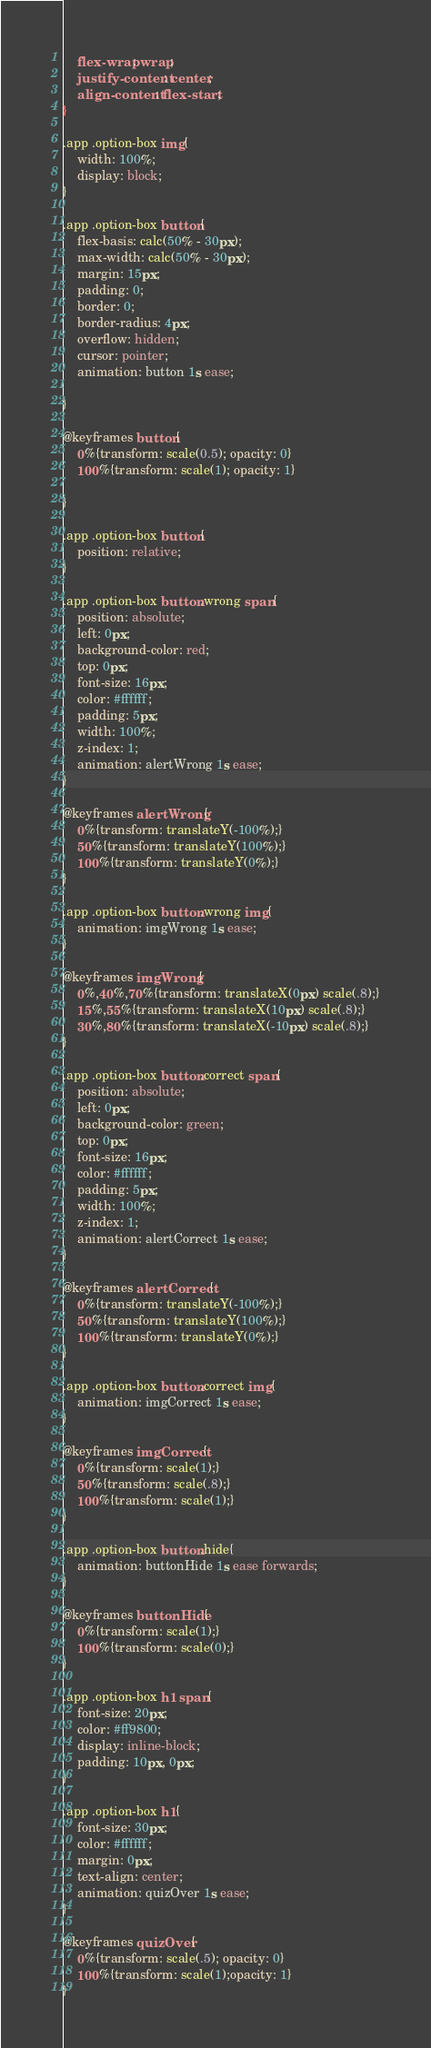Convert code to text. <code><loc_0><loc_0><loc_500><loc_500><_CSS_>	flex-wrap: wrap;
	justify-content: center;
	align-content: flex-start;
}

.app .option-box img{
	width: 100%;
	display: block;
}

.app .option-box button{
	flex-basis: calc(50% - 30px);
	max-width: calc(50% - 30px);
	margin: 15px;
	padding: 0;
	border: 0;
	border-radius: 4px;
	overflow: hidden;
	cursor: pointer;
	animation: button 1s ease;

}

@keyframes button{
	0%{transform: scale(0.5); opacity: 0}
	100%{transform: scale(1); opacity: 1}

}

.app .option-box button{
	position: relative;
}

.app .option-box button.wrong span{
	position: absolute;
	left: 0px;
	background-color: red;
	top: 0px;
	font-size: 16px;
	color: #ffffff;
	padding: 5px;
	width: 100%;
	z-index: 1;
	animation: alertWrong 1s ease;
}

@keyframes alertWrong{
	0%{transform: translateY(-100%);}
	50%{transform: translateY(100%);}
	100%{transform: translateY(0%);}
}

.app .option-box button.wrong img{
	animation: imgWrong 1s ease;
}

@keyframes imgWrong{
	0%,40%,70%{transform: translateX(0px) scale(.8);}
	15%,55%{transform: translateX(10px) scale(.8);}
	30%,80%{transform: translateX(-10px) scale(.8);}
}

.app .option-box button.correct span{
	position: absolute;
	left: 0px;
	background-color: green;
	top: 0px;
	font-size: 16px;
	color: #ffffff;
	padding: 5px;
	width: 100%;
	z-index: 1;
	animation: alertCorrect 1s ease;
}

@keyframes alertCorrect{
	0%{transform: translateY(-100%);}
	50%{transform: translateY(100%);}
	100%{transform: translateY(0%);}
}

.app .option-box button.correct img{
	animation: imgCorrect 1s ease;
}

@keyframes imgCorrect{
	0%{transform: scale(1);}
	50%{transform: scale(.8);}
	100%{transform: scale(1);}
}

.app .option-box button.hide{
	animation: buttonHide 1s ease forwards;
}

@keyframes buttonHide{
	0%{transform: scale(1);}
	100%{transform: scale(0);}
}

.app .option-box h1 span{
	font-size: 20px;
	color: #ff9800;
	display: inline-block;
	padding: 10px, 0px;
}

.app .option-box h1{
	font-size: 30px;
	color: #ffffff;
	margin: 0px;
	text-align: center;
	animation: quizOver 1s ease;
}

@keyframes quizOver{
	0%{transform: scale(.5); opacity: 0}
	100%{transform: scale(1);opacity: 1}
}</code> 